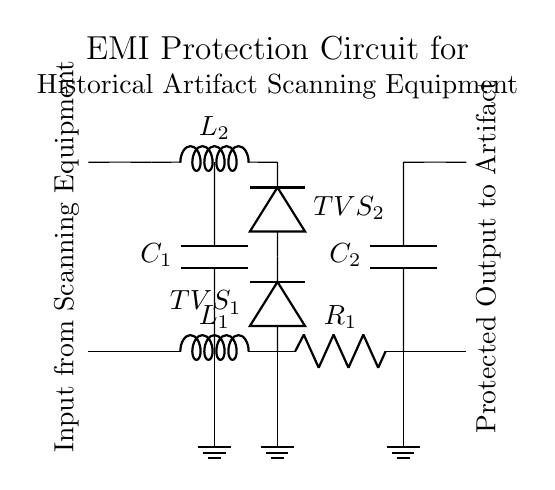What is the total number of inductors in the circuit? There are two inductors labeled L1 and L2 in the circuit diagram, both connected to the input from scanning equipment.
Answer: 2 What components are used to filter electromagnetic interference? The components used to filter electromagnetic interference are L1, L2, and C1, which form an EMI filter circuit.
Answer: L1, L2, C1 What is the function of the TVS diodes in this circuit? The TVS (Transient Voltage Suppression) diodes are used to protect the circuit from voltage spikes and transients, ensuring safe operation for sensitive equipment.
Answer: Voltage protection What is the role of the RC snubber in the circuit? The RC snubber, consisting of R1 and C2, is used to reduce voltage spikes and smooth out the output to the sensitive historical artifact scanning equipment.
Answer: Voltage smoothing How many outputs does the circuit produce? The circuit produces two outputs, one for the current and one for the voltage related to the protected scanning equipment.
Answer: 2 What is the labeling of the ground connections in the circuit? The ground connections are indicated by the ground symbols, which are placed at L1, TVS1, and R1 to establish a common reference point.
Answer: Ground symbols Which component is the primary source of filtering in the circuit? The primary source of filtering in the circuit is the capacitor C1, which is connected between both inductors as part of the EMI filter arrangement.
Answer: Capacitor C1 